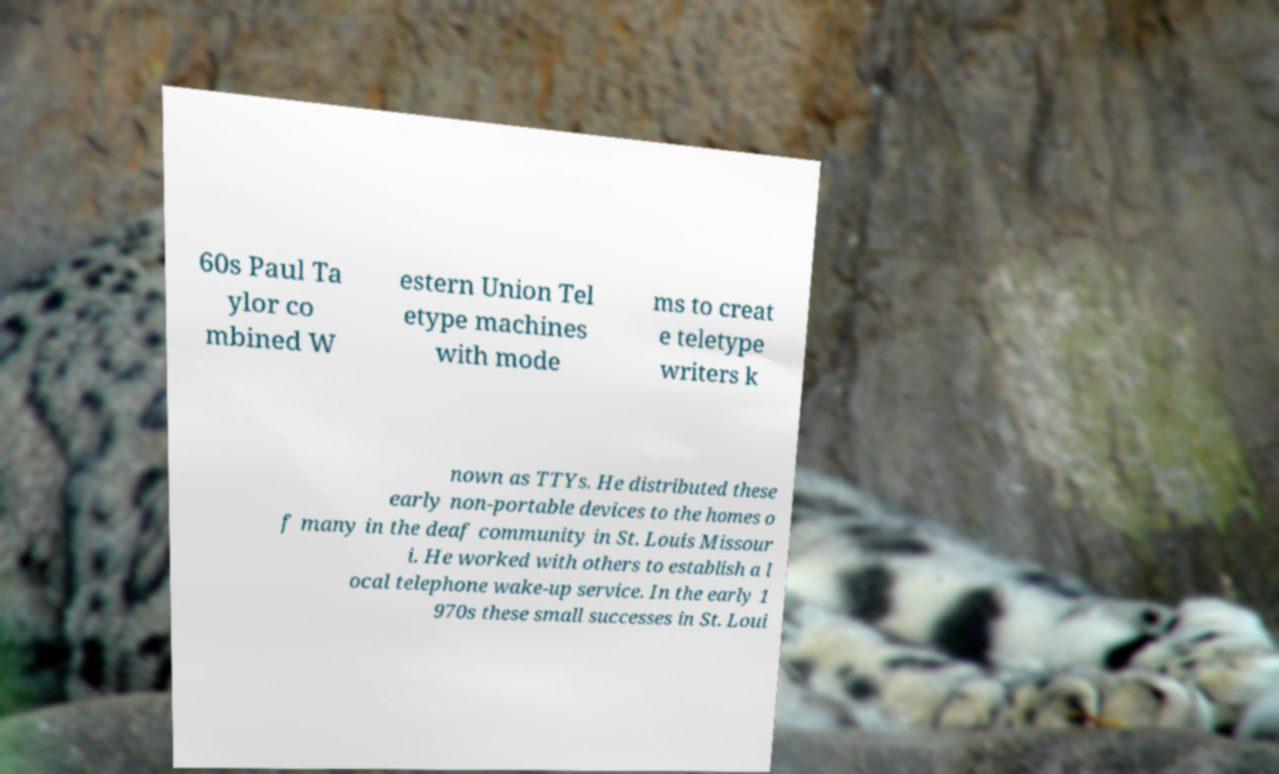Can you read and provide the text displayed in the image?This photo seems to have some interesting text. Can you extract and type it out for me? 60s Paul Ta ylor co mbined W estern Union Tel etype machines with mode ms to creat e teletype writers k nown as TTYs. He distributed these early non-portable devices to the homes o f many in the deaf community in St. Louis Missour i. He worked with others to establish a l ocal telephone wake-up service. In the early 1 970s these small successes in St. Loui 